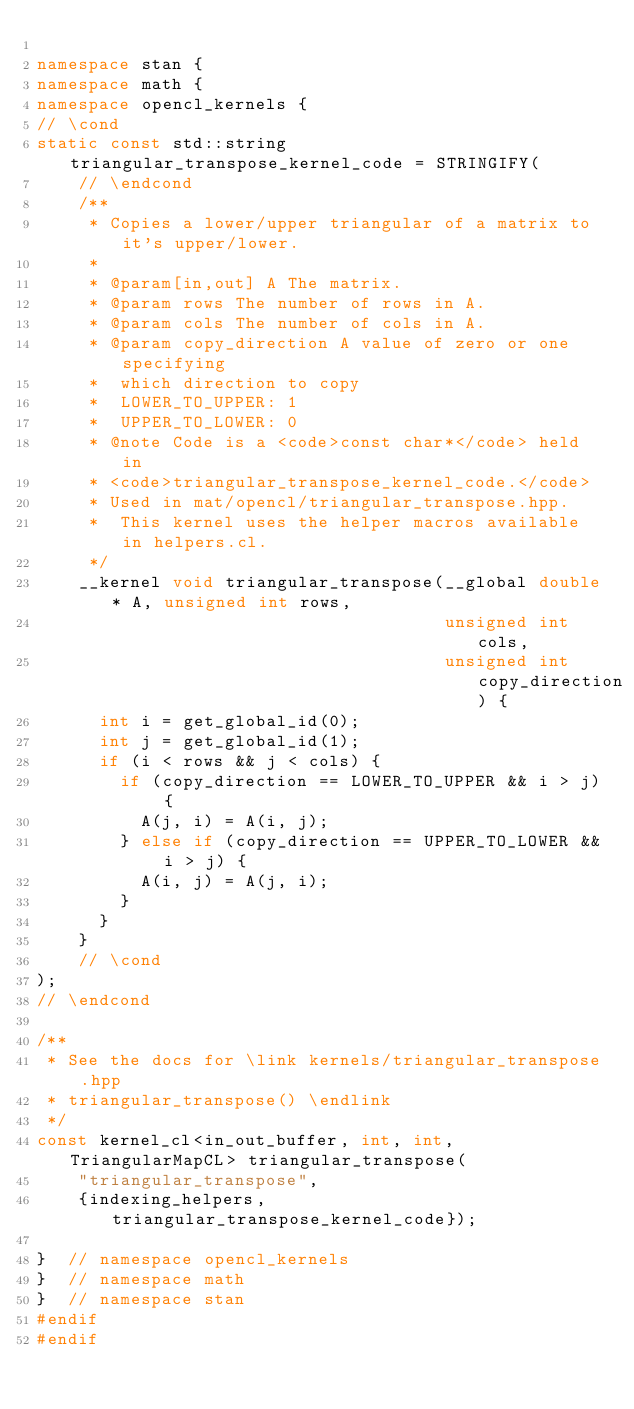<code> <loc_0><loc_0><loc_500><loc_500><_C++_>
namespace stan {
namespace math {
namespace opencl_kernels {
// \cond
static const std::string triangular_transpose_kernel_code = STRINGIFY(
    // \endcond
    /**
     * Copies a lower/upper triangular of a matrix to it's upper/lower.
     *
     * @param[in,out] A The matrix.
     * @param rows The number of rows in A.
     * @param cols The number of cols in A.
     * @param copy_direction A value of zero or one specifying
     *  which direction to copy
     *  LOWER_TO_UPPER: 1
     *  UPPER_TO_LOWER: 0
     * @note Code is a <code>const char*</code> held in
     * <code>triangular_transpose_kernel_code.</code>
     * Used in mat/opencl/triangular_transpose.hpp.
     *  This kernel uses the helper macros available in helpers.cl.
     */
    __kernel void triangular_transpose(__global double* A, unsigned int rows,
                                       unsigned int cols,
                                       unsigned int copy_direction) {
      int i = get_global_id(0);
      int j = get_global_id(1);
      if (i < rows && j < cols) {
        if (copy_direction == LOWER_TO_UPPER && i > j) {
          A(j, i) = A(i, j);
        } else if (copy_direction == UPPER_TO_LOWER && i > j) {
          A(i, j) = A(j, i);
        }
      }
    }
    // \cond
);
// \endcond

/**
 * See the docs for \link kernels/triangular_transpose.hpp
 * triangular_transpose() \endlink
 */
const kernel_cl<in_out_buffer, int, int, TriangularMapCL> triangular_transpose(
    "triangular_transpose",
    {indexing_helpers, triangular_transpose_kernel_code});

}  // namespace opencl_kernels
}  // namespace math
}  // namespace stan
#endif
#endif
</code> 